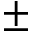Convert formula to latex. <formula><loc_0><loc_0><loc_500><loc_500>\pm</formula> 